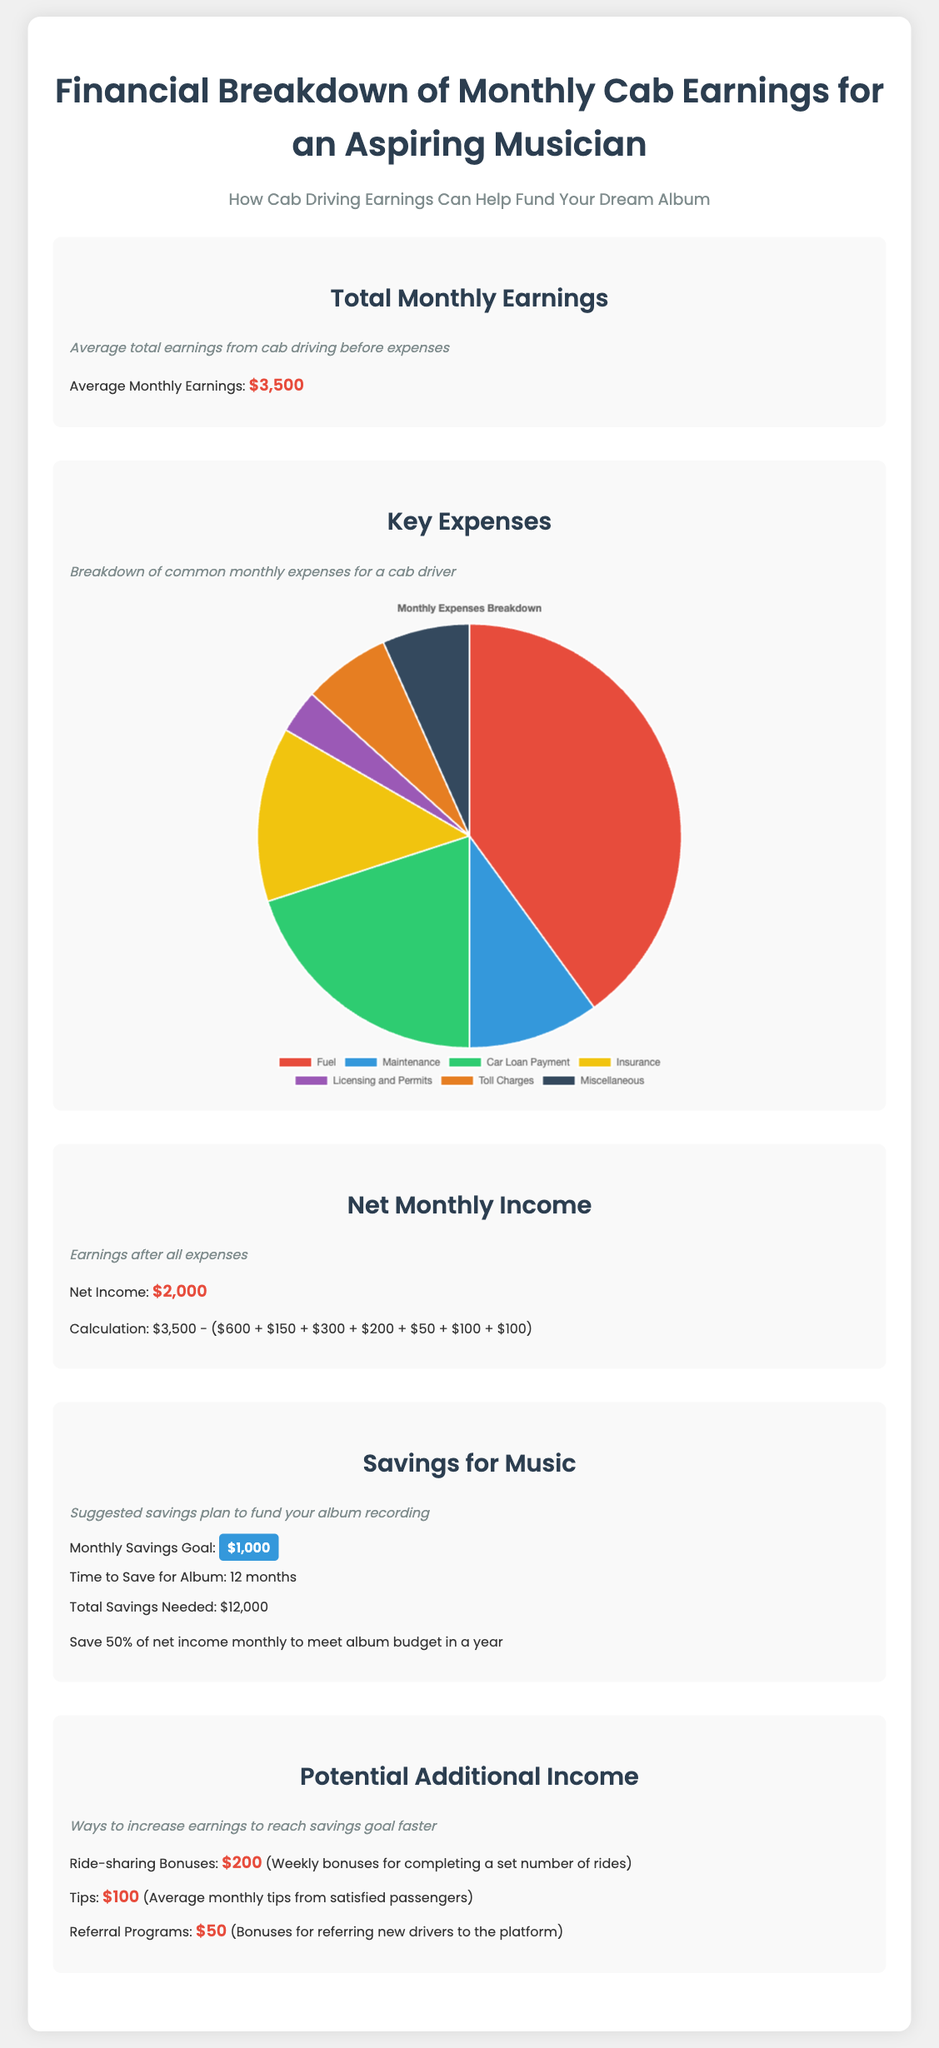What are the average monthly earnings? The document states that the average monthly earnings from cab driving are reported before expenses.
Answer: $3,500 What is the net income after expenses? The net income is the total earnings minus the sum of all expenses detailed in the document.
Answer: $2,000 How long will it take to save for the album? The document indicates that the time required to save the needed amount for the album is specified.
Answer: 12 months What is the monthly savings goal for the album? The document specifies a savings goal that is crucial for funding the album recording.
Answer: $1,000 What is the largest expense in the pie chart? The largest section of the expenses pie chart indicates the highest monthly expense category.
Answer: Fuel What is the total of the monthly expenses listed? By summing the expenses provided in the chart, we can determine the total monthly expenses.
Answer: $1,600 How much can one earn from ride-sharing bonuses? The document lists potential additional income sources along with their earnings.
Answer: $200 What percentage of net income is suggested to save monthly for the album? The document advises saving a specific fraction of the net income to meet savings goals.
Answer: 50% What is the purpose of this financial breakdown? The document's title and subtitle elucidate the main objective of the analysis presented.
Answer: To fund your dream album 